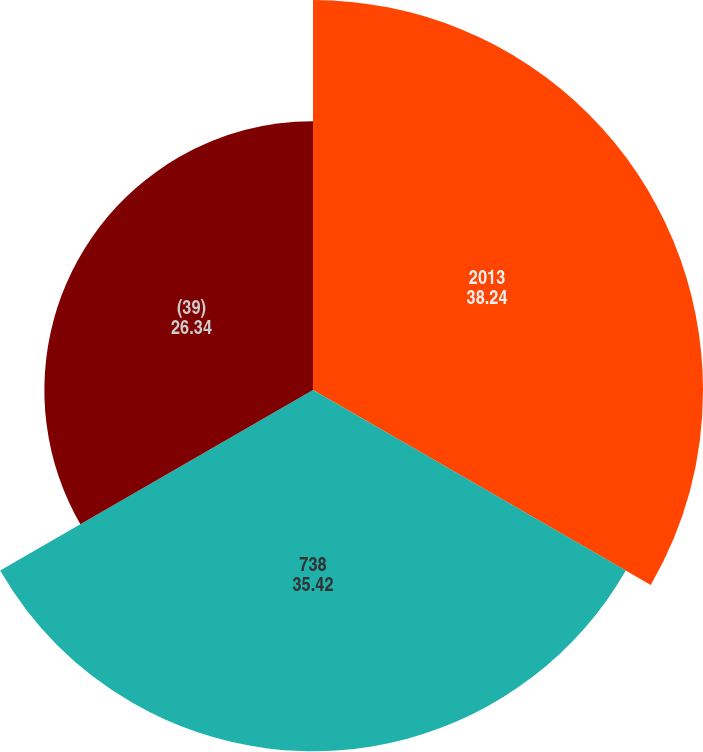Convert chart to OTSL. <chart><loc_0><loc_0><loc_500><loc_500><pie_chart><fcel>2013<fcel>738<fcel>(39)<nl><fcel>38.24%<fcel>35.42%<fcel>26.34%<nl></chart> 